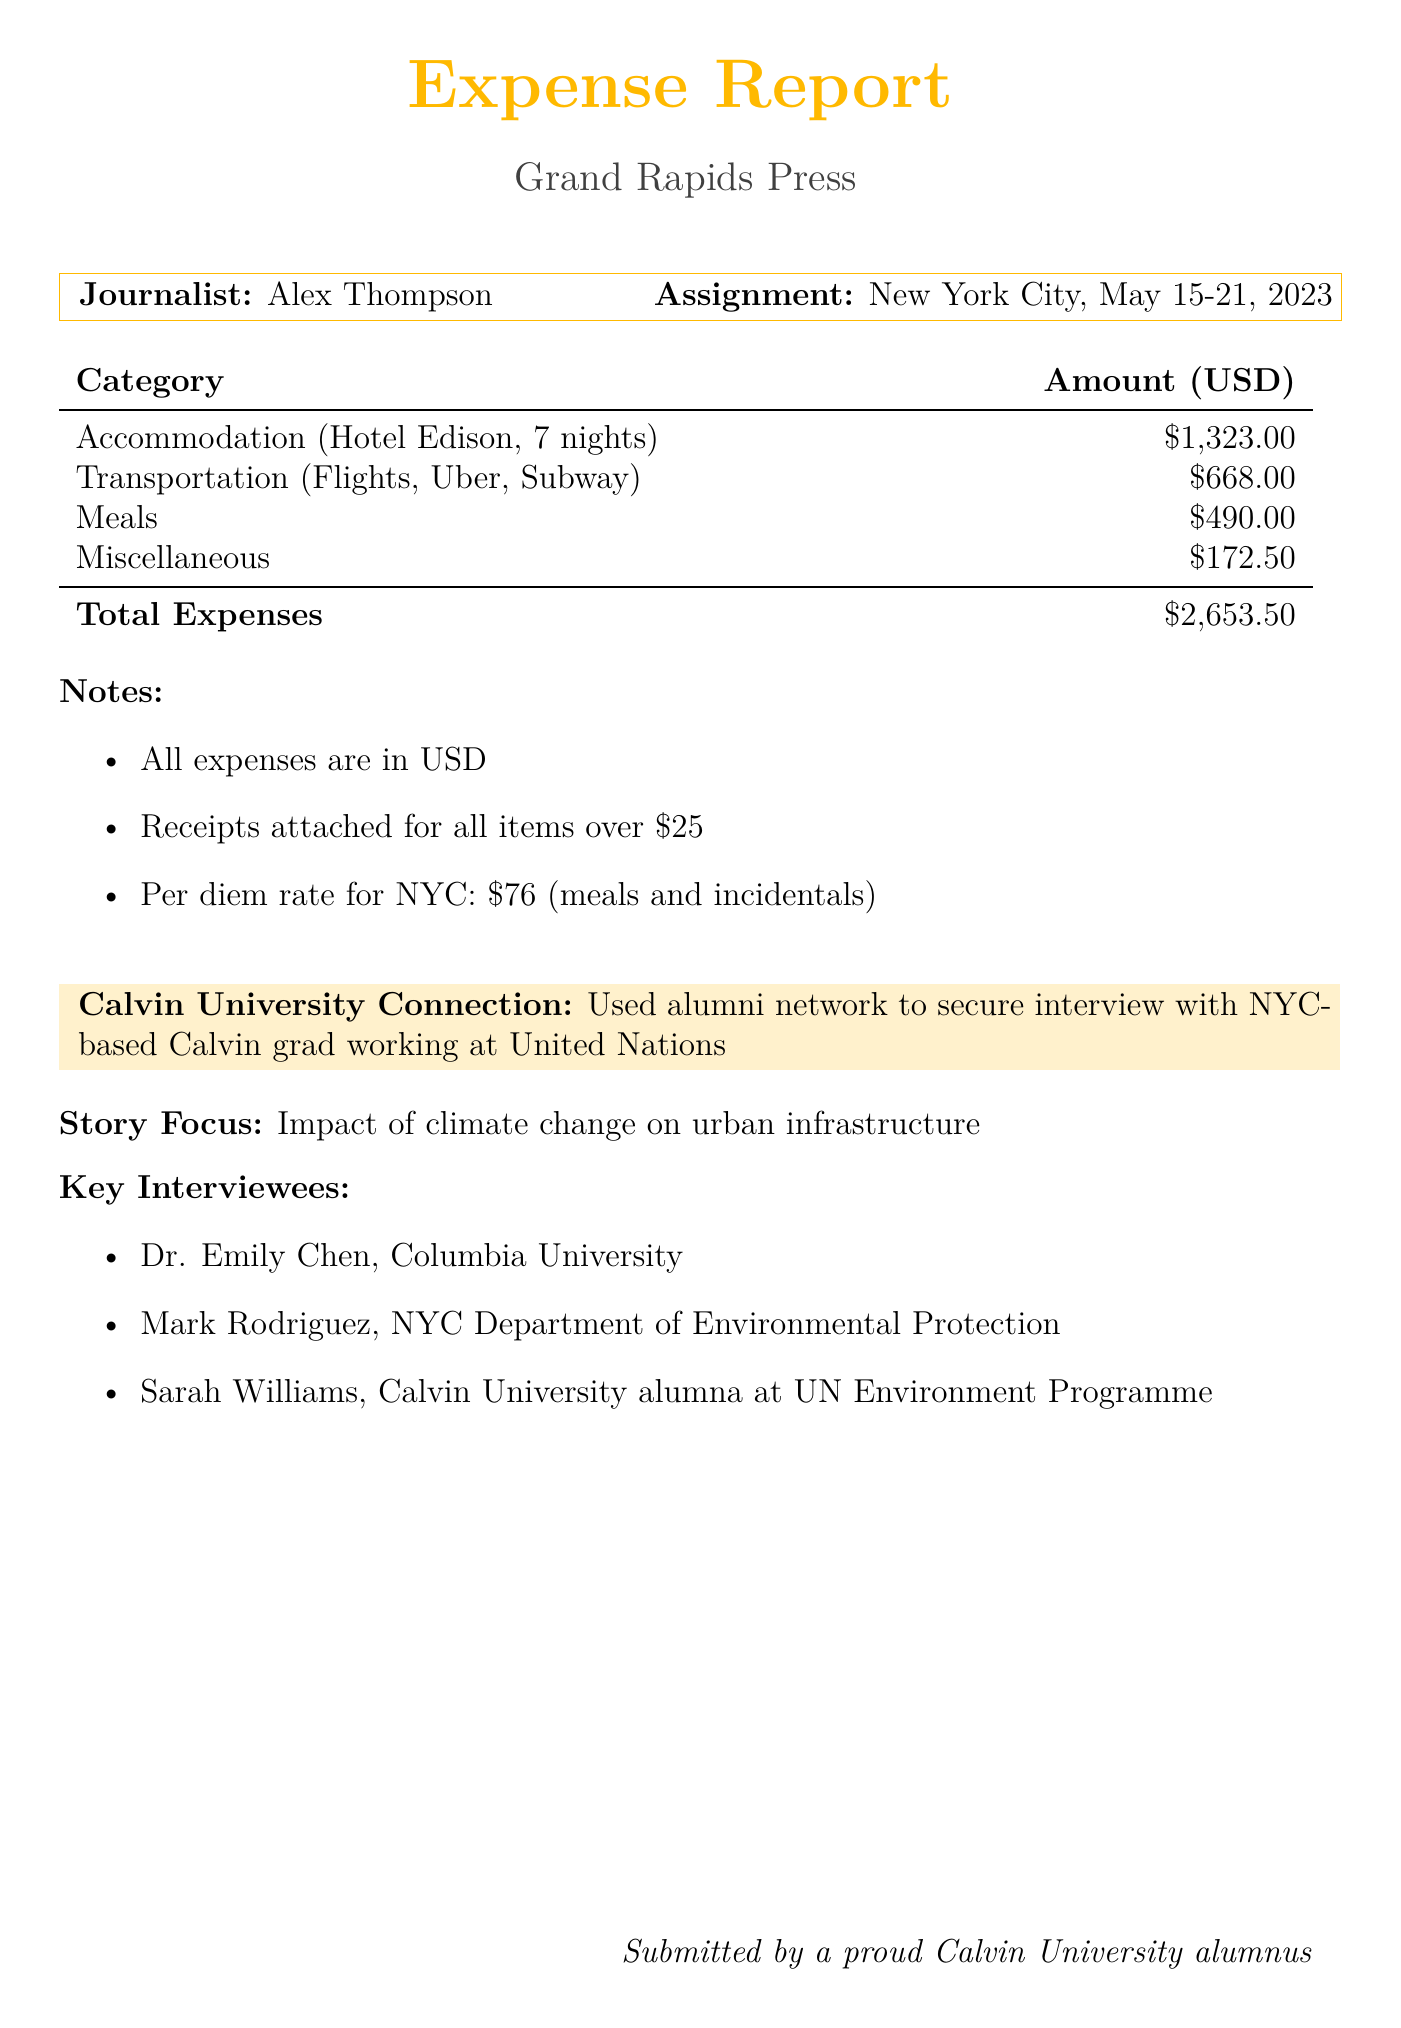What is the journalist's name? The journalist's name is provided at the beginning of the document.
Answer: Alex Thompson How many days did the assignment last? The assignment duration is explicitly stated in the document.
Answer: 7 days What was the total accommodation cost? The total for accommodation is listed in the summary of expenses in the document.
Answer: 1323.00 How much was spent on meals? The document lists the total cost specifically allocated for meals.
Answer: 490.00 What is the cost of the Delta Airlines flight? The cost of the Delta Airlines flight is mentioned in the transportation section of the document.
Answer: 425.00 What was the assignment location? The assignment location is given early in the document.
Answer: New York City How many interviewees are listed? The number of interviewees is detailed in the section describing the key interviewees.
Answer: 3 What is the per diem rate for NYC? The per diem rate is explicitly mentioned in the notes section of the document.
Answer: 76 What type of services did the laundry cost fall under? The document categorizes the laundry service under miscellaneous expenses.
Answer: Miscellaneous How did the journalist connect with an interviewee? The document mentions a specific source of networking for securing interviews.
Answer: Alumni network 